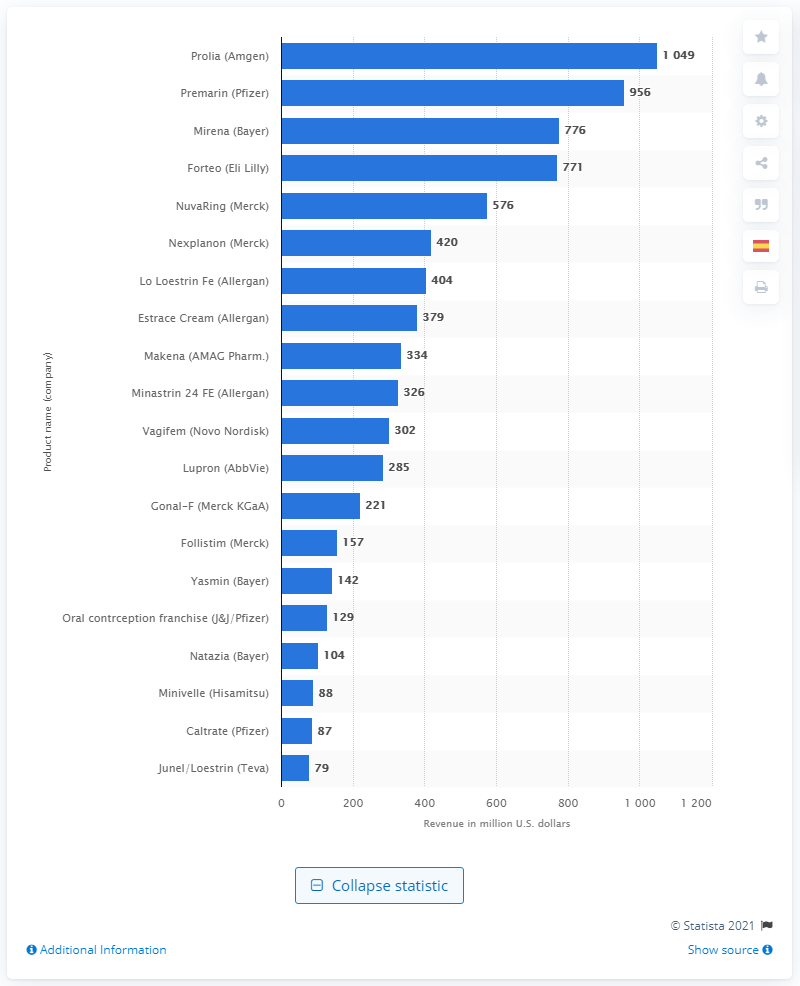Identify some key points in this picture. In 2016, the total revenue generated by Premarin in the U.S. was approximately $956 million. In 2016, the revenue generated by Prolia was 1049. 